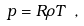Convert formula to latex. <formula><loc_0><loc_0><loc_500><loc_500>p = R \rho T \ ,</formula> 